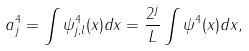<formula> <loc_0><loc_0><loc_500><loc_500>a ^ { 4 } _ { j } = \int \psi _ { j , l } ^ { 4 } ( x ) d x = \frac { 2 ^ { j } } { L } \int \psi ^ { 4 } ( x ) d x ,</formula> 